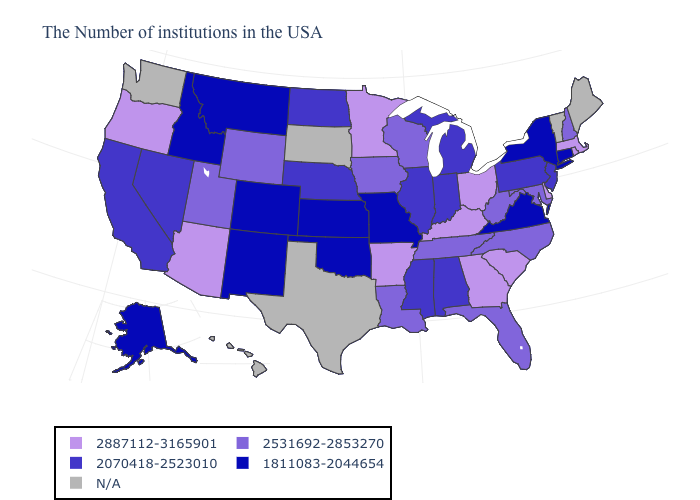What is the value of Kentucky?
Keep it brief. 2887112-3165901. How many symbols are there in the legend?
Short answer required. 5. What is the value of Iowa?
Keep it brief. 2531692-2853270. How many symbols are there in the legend?
Keep it brief. 5. Does Arizona have the highest value in the USA?
Be succinct. Yes. Does the first symbol in the legend represent the smallest category?
Write a very short answer. No. What is the lowest value in states that border Oklahoma?
Quick response, please. 1811083-2044654. Name the states that have a value in the range N/A?
Be succinct. Maine, Vermont, Texas, South Dakota, Washington, Hawaii. What is the value of Ohio?
Keep it brief. 2887112-3165901. Does Arkansas have the lowest value in the USA?
Be succinct. No. What is the highest value in states that border Arkansas?
Concise answer only. 2531692-2853270. 